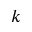<formula> <loc_0><loc_0><loc_500><loc_500>k</formula> 